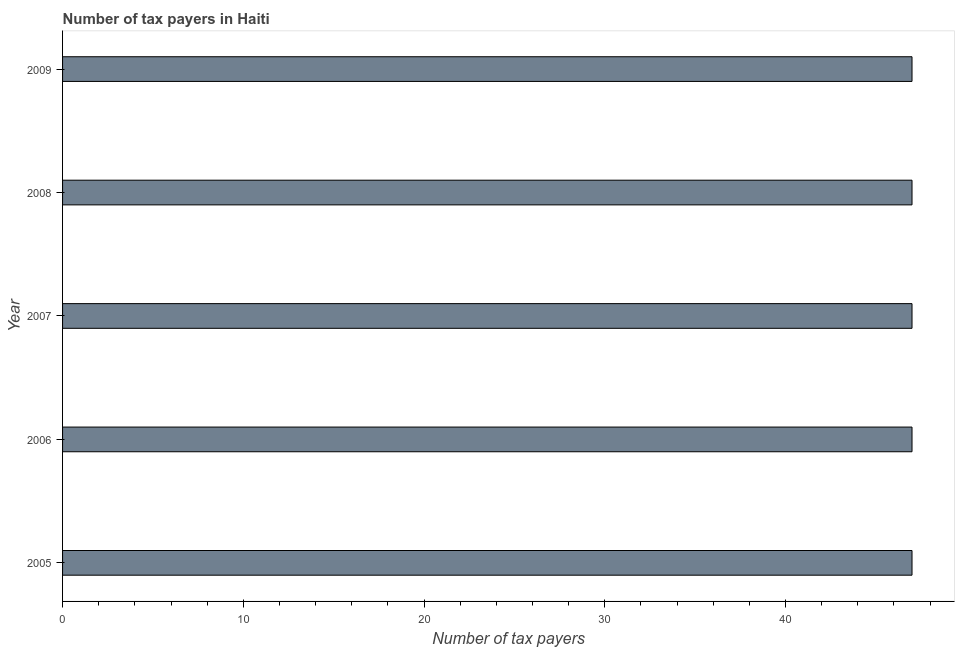Does the graph contain any zero values?
Provide a short and direct response. No. Does the graph contain grids?
Offer a terse response. No. What is the title of the graph?
Ensure brevity in your answer.  Number of tax payers in Haiti. What is the label or title of the X-axis?
Your answer should be very brief. Number of tax payers. What is the label or title of the Y-axis?
Provide a succinct answer. Year. What is the number of tax payers in 2005?
Provide a short and direct response. 47. Across all years, what is the minimum number of tax payers?
Your answer should be compact. 47. In which year was the number of tax payers maximum?
Provide a succinct answer. 2005. What is the sum of the number of tax payers?
Your response must be concise. 235. What is the median number of tax payers?
Ensure brevity in your answer.  47. In how many years, is the number of tax payers greater than 6 ?
Provide a short and direct response. 5. Is the difference between the number of tax payers in 2006 and 2009 greater than the difference between any two years?
Offer a terse response. Yes. Is the sum of the number of tax payers in 2006 and 2007 greater than the maximum number of tax payers across all years?
Your answer should be very brief. Yes. What is the difference between the highest and the lowest number of tax payers?
Ensure brevity in your answer.  0. How many years are there in the graph?
Ensure brevity in your answer.  5. What is the Number of tax payers in 2005?
Offer a very short reply. 47. What is the Number of tax payers of 2006?
Provide a succinct answer. 47. What is the difference between the Number of tax payers in 2006 and 2008?
Provide a short and direct response. 0. What is the difference between the Number of tax payers in 2006 and 2009?
Give a very brief answer. 0. What is the difference between the Number of tax payers in 2008 and 2009?
Offer a terse response. 0. What is the ratio of the Number of tax payers in 2005 to that in 2006?
Give a very brief answer. 1. What is the ratio of the Number of tax payers in 2005 to that in 2007?
Offer a terse response. 1. What is the ratio of the Number of tax payers in 2005 to that in 2008?
Offer a very short reply. 1. What is the ratio of the Number of tax payers in 2005 to that in 2009?
Give a very brief answer. 1. What is the ratio of the Number of tax payers in 2006 to that in 2007?
Keep it short and to the point. 1. What is the ratio of the Number of tax payers in 2006 to that in 2008?
Provide a succinct answer. 1. What is the ratio of the Number of tax payers in 2007 to that in 2009?
Give a very brief answer. 1. What is the ratio of the Number of tax payers in 2008 to that in 2009?
Offer a very short reply. 1. 